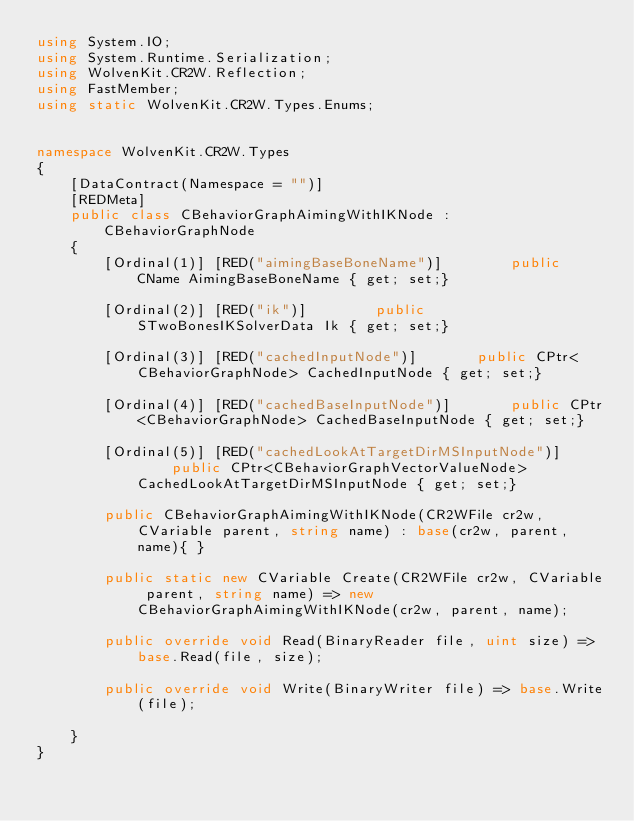Convert code to text. <code><loc_0><loc_0><loc_500><loc_500><_C#_>using System.IO;
using System.Runtime.Serialization;
using WolvenKit.CR2W.Reflection;
using FastMember;
using static WolvenKit.CR2W.Types.Enums;


namespace WolvenKit.CR2W.Types
{
	[DataContract(Namespace = "")]
	[REDMeta]
	public class CBehaviorGraphAimingWithIKNode : CBehaviorGraphNode
	{
		[Ordinal(1)] [RED("aimingBaseBoneName")] 		public CName AimingBaseBoneName { get; set;}

		[Ordinal(2)] [RED("ik")] 		public STwoBonesIKSolverData Ik { get; set;}

		[Ordinal(3)] [RED("cachedInputNode")] 		public CPtr<CBehaviorGraphNode> CachedInputNode { get; set;}

		[Ordinal(4)] [RED("cachedBaseInputNode")] 		public CPtr<CBehaviorGraphNode> CachedBaseInputNode { get; set;}

		[Ordinal(5)] [RED("cachedLookAtTargetDirMSInputNode")] 		public CPtr<CBehaviorGraphVectorValueNode> CachedLookAtTargetDirMSInputNode { get; set;}

		public CBehaviorGraphAimingWithIKNode(CR2WFile cr2w, CVariable parent, string name) : base(cr2w, parent, name){ }

		public static new CVariable Create(CR2WFile cr2w, CVariable parent, string name) => new CBehaviorGraphAimingWithIKNode(cr2w, parent, name);

		public override void Read(BinaryReader file, uint size) => base.Read(file, size);

		public override void Write(BinaryWriter file) => base.Write(file);

	}
}</code> 